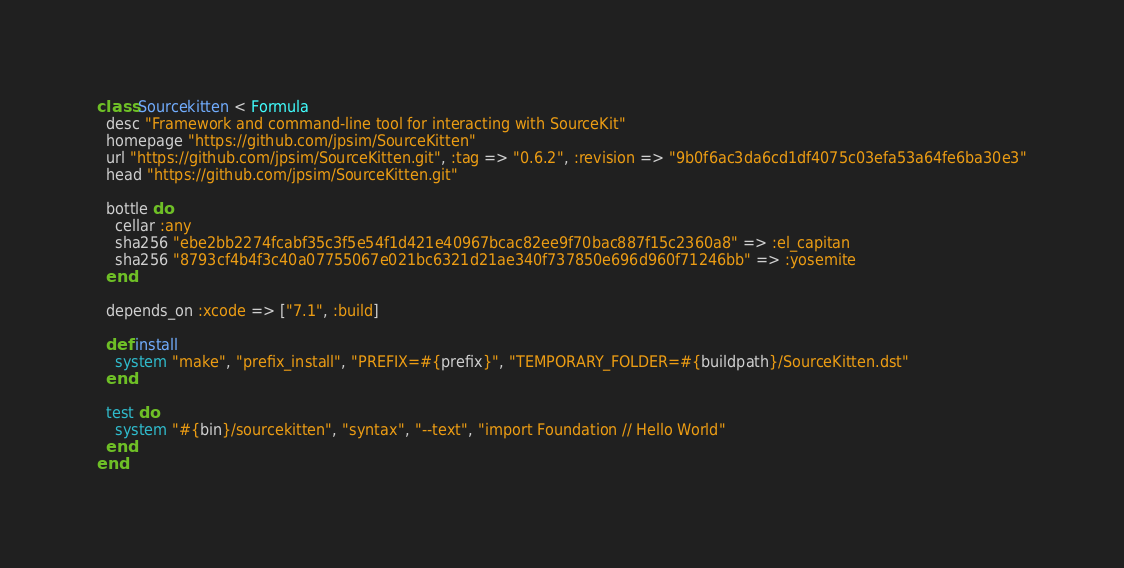<code> <loc_0><loc_0><loc_500><loc_500><_Ruby_>class Sourcekitten < Formula
  desc "Framework and command-line tool for interacting with SourceKit"
  homepage "https://github.com/jpsim/SourceKitten"
  url "https://github.com/jpsim/SourceKitten.git", :tag => "0.6.2", :revision => "9b0f6ac3da6cd1df4075c03efa53a64fe6ba30e3"
  head "https://github.com/jpsim/SourceKitten.git"

  bottle do
    cellar :any
    sha256 "ebe2bb2274fcabf35c3f5e54f1d421e40967bcac82ee9f70bac887f15c2360a8" => :el_capitan
    sha256 "8793cf4b4f3c40a07755067e021bc6321d21ae340f737850e696d960f71246bb" => :yosemite
  end

  depends_on :xcode => ["7.1", :build]

  def install
    system "make", "prefix_install", "PREFIX=#{prefix}", "TEMPORARY_FOLDER=#{buildpath}/SourceKitten.dst"
  end

  test do
    system "#{bin}/sourcekitten", "syntax", "--text", "import Foundation // Hello World"
  end
end
</code> 